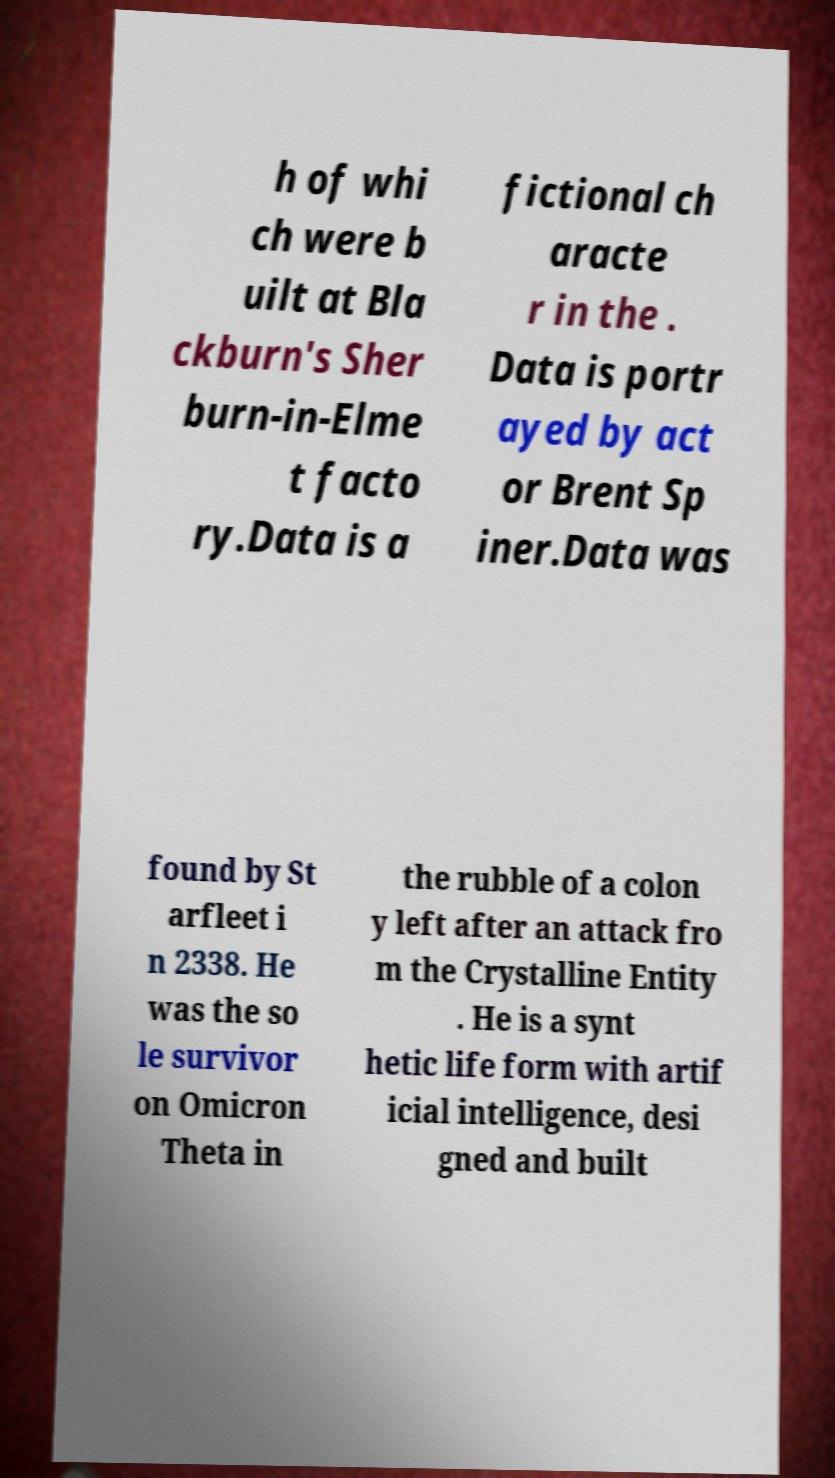Could you assist in decoding the text presented in this image and type it out clearly? h of whi ch were b uilt at Bla ckburn's Sher burn-in-Elme t facto ry.Data is a fictional ch aracte r in the . Data is portr ayed by act or Brent Sp iner.Data was found by St arfleet i n 2338. He was the so le survivor on Omicron Theta in the rubble of a colon y left after an attack fro m the Crystalline Entity . He is a synt hetic life form with artif icial intelligence, desi gned and built 